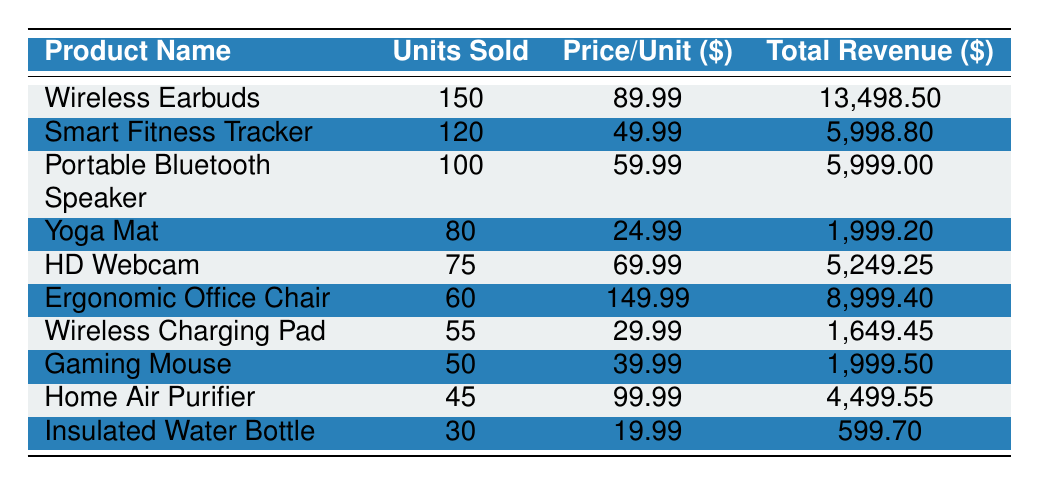What is the total revenue generated by the Wireless Earbuds? The Wireless Earbuds sold 150 units at a price of 89.99 each. To find the total revenue, multiply the units sold by the price per unit: 150 * 89.99 = 13,498.50.
Answer: 13,498.50 How many units of the Smart Fitness Tracker were sold? The Smart Fitness Tracker had a recorded sale of 120 units sold. This value is directly present in the table.
Answer: 120 Which product generated the lowest revenue, and what is that revenue? The Insulated Water Bottle sold 30 units at a price of 19.99 each. Total revenue is calculated as 30 * 19.99 = 599.70, which is lower than any other product's revenue as shown in the table.
Answer: Insulated Water Bottle, 599.70 What is the average price per unit of the top-selling products? To calculate the average price per unit, first sum the price per unit of all products: 89.99 + 49.99 + 59.99 + 24.99 + 69.99 + 149.99 + 29.99 + 39.99 + 99.99 + 19.99 =  618.90. There are 10 products, so the average price is 618.90 / 10 = 61.89.
Answer: 61.89 Is the total revenue from the Yoga Mat greater than the total revenue from the Gaming Mouse? The total revenue for the Yoga Mat is 80 units sold at 24.99 each, amounting to 1,999.20 (80 * 24.99). The Gaming Mouse sold 50 units at 39.99, resulting in total revenue of 1,999.50. Therefore, the total revenue from the Yoga Mat is less than that from the Gaming Mouse.
Answer: No Which product has the highest number of units sold and what is that number? The product with the highest number of units sold is the Wireless Earbuds at 150 units. This number is stated directly in the table.
Answer: 150 What is the difference in units sold between the Portable Bluetooth Speaker and the Ergonomic Office Chair? The Portable Bluetooth Speaker sold 100 units while the Ergonomic Office Chair sold 60 units. The difference is calculated as 100 - 60 = 40.
Answer: 40 Is the total units sold for all products greater than 800? Adding the units sold: 150 + 120 + 100 + 80 + 75 + 60 + 55 + 50 + 45 + 30 = 715. Since 715 is less than 800, the statement is false.
Answer: No What percentage of total sales did the Smart Fitness Tracker contribute? Total units sold across all products = 715. The Smart Fitness Tracker sold 120 units. The percentage contribution can be calculated as (120 / 715) * 100 = 16.76%.
Answer: 16.76% 